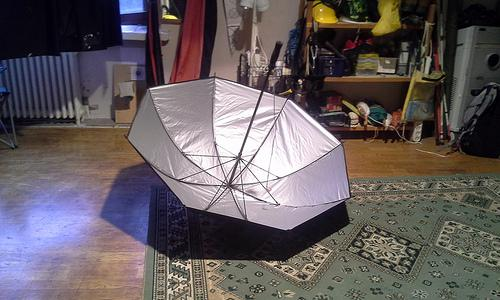Question: what is it?
Choices:
A. Torch.
B. Umbrella.
C. Paper plate.
D. Cup.
Answer with the letter. Answer: B Question: who will use it?
Choices:
A. The dog.
B. The cat.
C. A person.
D. The horse.
Answer with the letter. Answer: C Question: when will they use it?
Choices:
A. Never.
B. Soon.
C. Tomorrow.
D. Next week.
Answer with the letter. Answer: B Question: why is it open?
Choices:
A. To use.
B. He forgot to close it.
C. To take out the soda.
D. To let him out.
Answer with the letter. Answer: A Question: how many umbrellas?
Choices:
A. 2.
B. 1.
C. 3.
D. 4.
Answer with the letter. Answer: B 